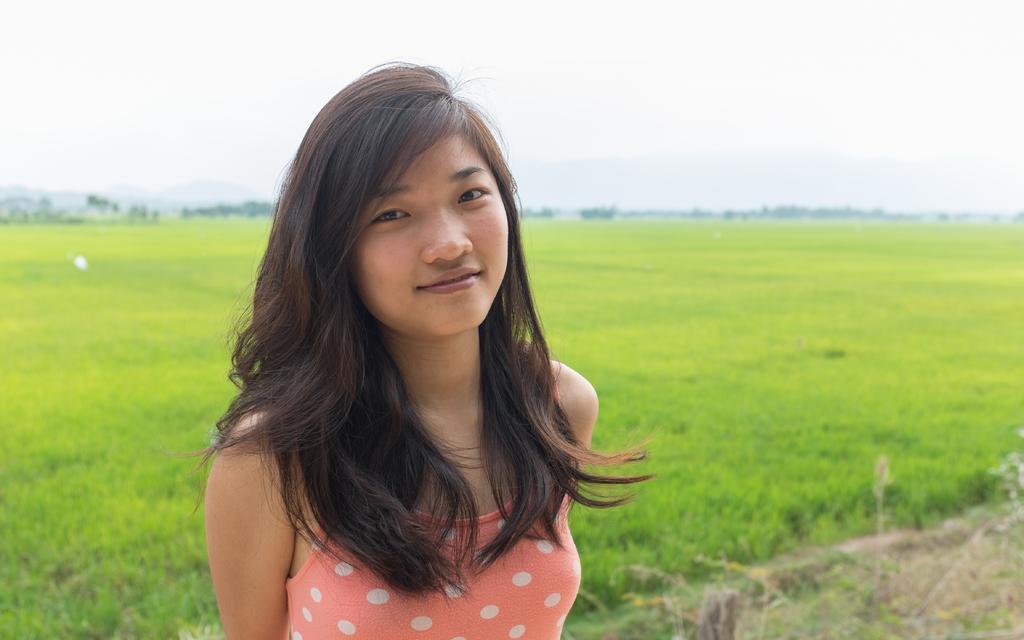How would you summarize this image in a sentence or two? Here I can see a woman smiling and giving pose for the picture. In the background, I can see the field and there are many trees. At the top of the image I can see the sky. 